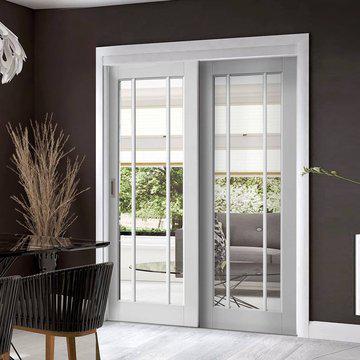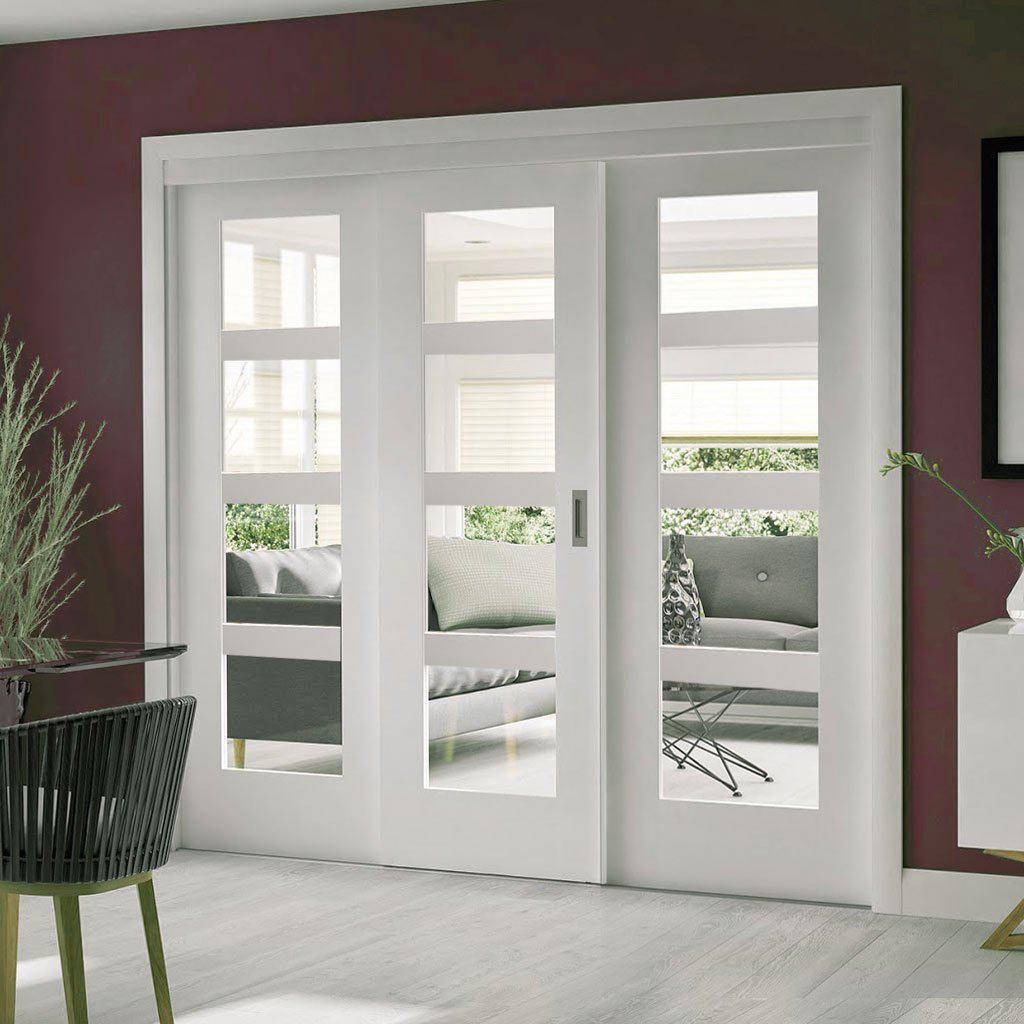The first image is the image on the left, the second image is the image on the right. Assess this claim about the two images: "There is a potted plant in the image on the left.". Correct or not? Answer yes or no. Yes. 